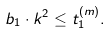Convert formula to latex. <formula><loc_0><loc_0><loc_500><loc_500>b _ { 1 } \cdot k ^ { 2 } \leq t ^ { ( m ) } _ { 1 } .</formula> 